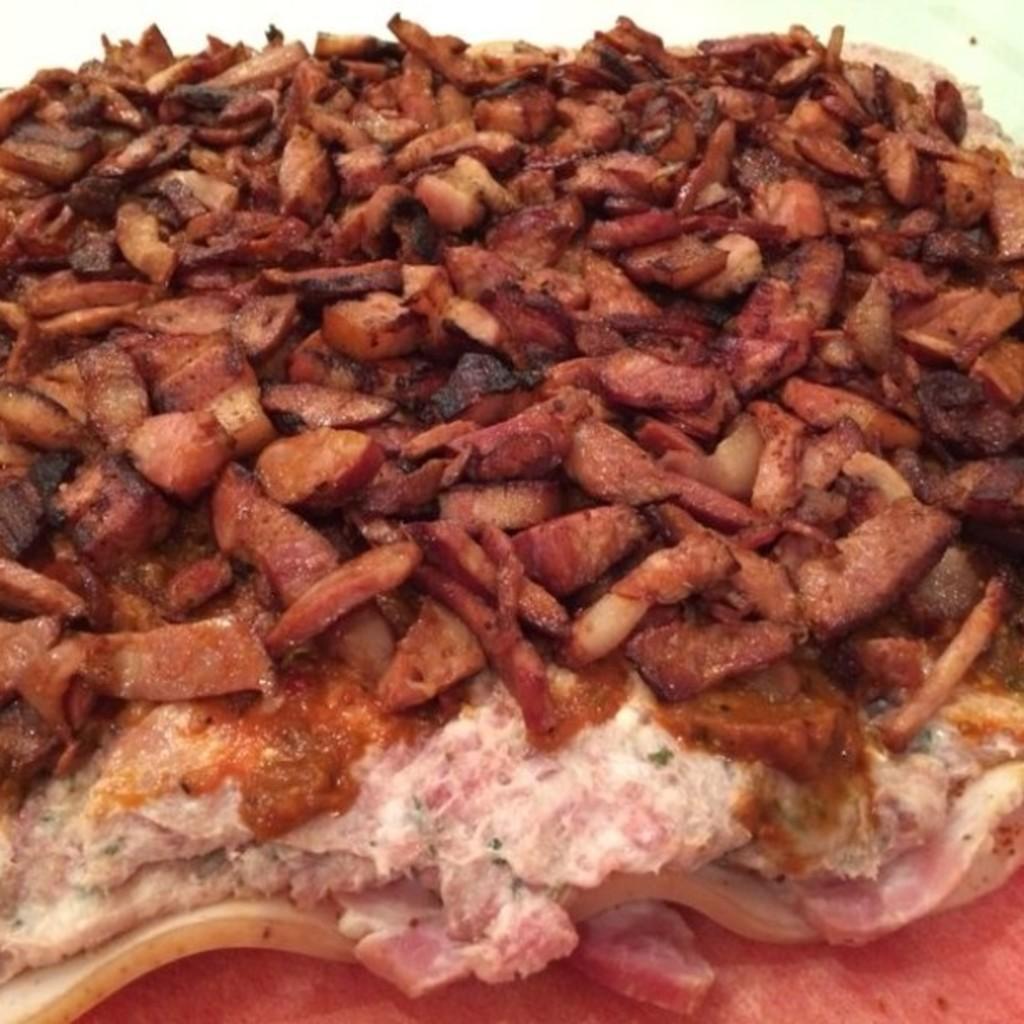Please provide a concise description of this image. In this picture we can see the meet pieces and fried pieces which is kept on the table. In the top right corner there is a wall. 